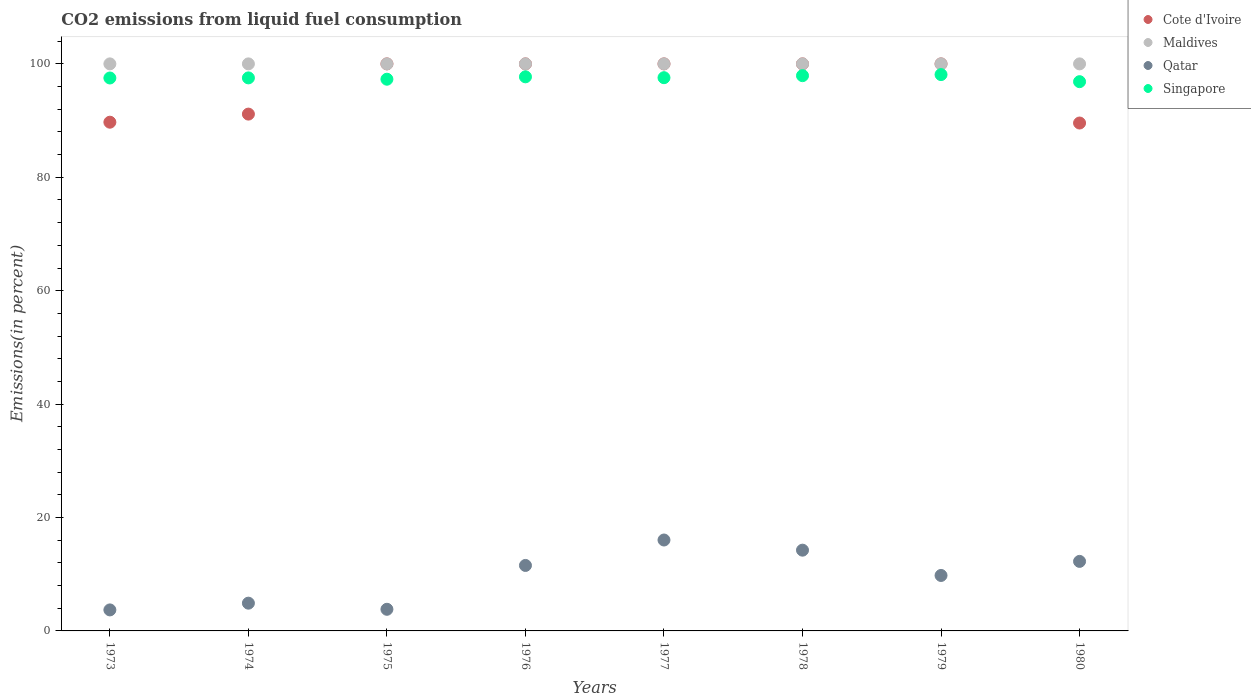How many different coloured dotlines are there?
Your response must be concise. 4. What is the total CO2 emitted in Singapore in 1975?
Provide a succinct answer. 97.3. Across all years, what is the maximum total CO2 emitted in Maldives?
Give a very brief answer. 100. In which year was the total CO2 emitted in Cote d'Ivoire maximum?
Make the answer very short. 1975. In which year was the total CO2 emitted in Maldives minimum?
Your response must be concise. 1973. What is the total total CO2 emitted in Cote d'Ivoire in the graph?
Provide a short and direct response. 770.43. What is the difference between the total CO2 emitted in Maldives in 1974 and that in 1980?
Make the answer very short. 0. What is the difference between the total CO2 emitted in Maldives in 1975 and the total CO2 emitted in Qatar in 1977?
Provide a succinct answer. 83.97. In the year 1974, what is the difference between the total CO2 emitted in Qatar and total CO2 emitted in Maldives?
Offer a terse response. -95.1. What is the ratio of the total CO2 emitted in Singapore in 1974 to that in 1978?
Your response must be concise. 1. Is the total CO2 emitted in Singapore in 1973 less than that in 1974?
Give a very brief answer. Yes. What is the difference between the highest and the second highest total CO2 emitted in Qatar?
Offer a very short reply. 1.79. What is the difference between the highest and the lowest total CO2 emitted in Qatar?
Your answer should be very brief. 12.33. In how many years, is the total CO2 emitted in Cote d'Ivoire greater than the average total CO2 emitted in Cote d'Ivoire taken over all years?
Your answer should be compact. 5. Is the sum of the total CO2 emitted in Cote d'Ivoire in 1973 and 1976 greater than the maximum total CO2 emitted in Singapore across all years?
Your answer should be compact. Yes. Is it the case that in every year, the sum of the total CO2 emitted in Cote d'Ivoire and total CO2 emitted in Singapore  is greater than the total CO2 emitted in Maldives?
Provide a succinct answer. Yes. Is the total CO2 emitted in Maldives strictly greater than the total CO2 emitted in Cote d'Ivoire over the years?
Provide a succinct answer. No. What is the difference between two consecutive major ticks on the Y-axis?
Give a very brief answer. 20. Does the graph contain any zero values?
Make the answer very short. No. How many legend labels are there?
Provide a short and direct response. 4. What is the title of the graph?
Offer a very short reply. CO2 emissions from liquid fuel consumption. What is the label or title of the Y-axis?
Keep it short and to the point. Emissions(in percent). What is the Emissions(in percent) in Cote d'Ivoire in 1973?
Offer a very short reply. 89.71. What is the Emissions(in percent) in Qatar in 1973?
Give a very brief answer. 3.71. What is the Emissions(in percent) of Singapore in 1973?
Provide a succinct answer. 97.51. What is the Emissions(in percent) in Cote d'Ivoire in 1974?
Make the answer very short. 91.14. What is the Emissions(in percent) of Maldives in 1974?
Make the answer very short. 100. What is the Emissions(in percent) of Qatar in 1974?
Provide a succinct answer. 4.9. What is the Emissions(in percent) in Singapore in 1974?
Offer a terse response. 97.53. What is the Emissions(in percent) in Cote d'Ivoire in 1975?
Your response must be concise. 100. What is the Emissions(in percent) in Qatar in 1975?
Offer a terse response. 3.82. What is the Emissions(in percent) in Singapore in 1975?
Provide a succinct answer. 97.3. What is the Emissions(in percent) of Qatar in 1976?
Your answer should be very brief. 11.55. What is the Emissions(in percent) of Singapore in 1976?
Your answer should be very brief. 97.72. What is the Emissions(in percent) in Cote d'Ivoire in 1977?
Your answer should be compact. 100. What is the Emissions(in percent) in Qatar in 1977?
Your answer should be very brief. 16.03. What is the Emissions(in percent) in Singapore in 1977?
Provide a short and direct response. 97.56. What is the Emissions(in percent) of Cote d'Ivoire in 1978?
Offer a terse response. 100. What is the Emissions(in percent) of Maldives in 1978?
Offer a terse response. 100. What is the Emissions(in percent) of Qatar in 1978?
Offer a very short reply. 14.24. What is the Emissions(in percent) of Singapore in 1978?
Provide a succinct answer. 97.92. What is the Emissions(in percent) of Maldives in 1979?
Ensure brevity in your answer.  100. What is the Emissions(in percent) of Qatar in 1979?
Keep it short and to the point. 9.78. What is the Emissions(in percent) of Singapore in 1979?
Make the answer very short. 98.11. What is the Emissions(in percent) in Cote d'Ivoire in 1980?
Offer a very short reply. 89.57. What is the Emissions(in percent) of Qatar in 1980?
Offer a terse response. 12.26. What is the Emissions(in percent) in Singapore in 1980?
Provide a succinct answer. 96.86. Across all years, what is the maximum Emissions(in percent) of Cote d'Ivoire?
Offer a terse response. 100. Across all years, what is the maximum Emissions(in percent) in Qatar?
Your answer should be compact. 16.03. Across all years, what is the maximum Emissions(in percent) in Singapore?
Give a very brief answer. 98.11. Across all years, what is the minimum Emissions(in percent) in Cote d'Ivoire?
Make the answer very short. 89.57. Across all years, what is the minimum Emissions(in percent) of Qatar?
Keep it short and to the point. 3.71. Across all years, what is the minimum Emissions(in percent) in Singapore?
Give a very brief answer. 96.86. What is the total Emissions(in percent) in Cote d'Ivoire in the graph?
Give a very brief answer. 770.43. What is the total Emissions(in percent) in Maldives in the graph?
Provide a succinct answer. 800. What is the total Emissions(in percent) in Qatar in the graph?
Your response must be concise. 76.28. What is the total Emissions(in percent) of Singapore in the graph?
Provide a short and direct response. 780.51. What is the difference between the Emissions(in percent) in Cote d'Ivoire in 1973 and that in 1974?
Make the answer very short. -1.43. What is the difference between the Emissions(in percent) in Maldives in 1973 and that in 1974?
Your response must be concise. 0. What is the difference between the Emissions(in percent) in Qatar in 1973 and that in 1974?
Your answer should be very brief. -1.19. What is the difference between the Emissions(in percent) of Singapore in 1973 and that in 1974?
Your answer should be very brief. -0.02. What is the difference between the Emissions(in percent) of Cote d'Ivoire in 1973 and that in 1975?
Your answer should be very brief. -10.29. What is the difference between the Emissions(in percent) in Qatar in 1973 and that in 1975?
Keep it short and to the point. -0.11. What is the difference between the Emissions(in percent) in Singapore in 1973 and that in 1975?
Your answer should be compact. 0.22. What is the difference between the Emissions(in percent) of Cote d'Ivoire in 1973 and that in 1976?
Offer a terse response. -10.29. What is the difference between the Emissions(in percent) in Qatar in 1973 and that in 1976?
Your answer should be very brief. -7.84. What is the difference between the Emissions(in percent) of Singapore in 1973 and that in 1976?
Provide a short and direct response. -0.21. What is the difference between the Emissions(in percent) in Cote d'Ivoire in 1973 and that in 1977?
Offer a terse response. -10.29. What is the difference between the Emissions(in percent) in Qatar in 1973 and that in 1977?
Your answer should be compact. -12.33. What is the difference between the Emissions(in percent) of Singapore in 1973 and that in 1977?
Provide a short and direct response. -0.05. What is the difference between the Emissions(in percent) in Cote d'Ivoire in 1973 and that in 1978?
Your answer should be very brief. -10.29. What is the difference between the Emissions(in percent) of Qatar in 1973 and that in 1978?
Your answer should be compact. -10.54. What is the difference between the Emissions(in percent) in Singapore in 1973 and that in 1978?
Provide a short and direct response. -0.41. What is the difference between the Emissions(in percent) of Cote d'Ivoire in 1973 and that in 1979?
Provide a succinct answer. -10.29. What is the difference between the Emissions(in percent) in Maldives in 1973 and that in 1979?
Your answer should be very brief. 0. What is the difference between the Emissions(in percent) in Qatar in 1973 and that in 1979?
Give a very brief answer. -6.07. What is the difference between the Emissions(in percent) in Singapore in 1973 and that in 1979?
Offer a terse response. -0.6. What is the difference between the Emissions(in percent) of Cote d'Ivoire in 1973 and that in 1980?
Offer a very short reply. 0.14. What is the difference between the Emissions(in percent) of Qatar in 1973 and that in 1980?
Provide a short and direct response. -8.56. What is the difference between the Emissions(in percent) of Singapore in 1973 and that in 1980?
Keep it short and to the point. 0.65. What is the difference between the Emissions(in percent) of Cote d'Ivoire in 1974 and that in 1975?
Your response must be concise. -8.86. What is the difference between the Emissions(in percent) of Maldives in 1974 and that in 1975?
Give a very brief answer. 0. What is the difference between the Emissions(in percent) in Qatar in 1974 and that in 1975?
Your answer should be very brief. 1.08. What is the difference between the Emissions(in percent) of Singapore in 1974 and that in 1975?
Your answer should be very brief. 0.23. What is the difference between the Emissions(in percent) of Cote d'Ivoire in 1974 and that in 1976?
Ensure brevity in your answer.  -8.86. What is the difference between the Emissions(in percent) in Maldives in 1974 and that in 1976?
Offer a terse response. 0. What is the difference between the Emissions(in percent) in Qatar in 1974 and that in 1976?
Ensure brevity in your answer.  -6.65. What is the difference between the Emissions(in percent) in Singapore in 1974 and that in 1976?
Your answer should be very brief. -0.19. What is the difference between the Emissions(in percent) of Cote d'Ivoire in 1974 and that in 1977?
Your answer should be very brief. -8.86. What is the difference between the Emissions(in percent) in Qatar in 1974 and that in 1977?
Your response must be concise. -11.14. What is the difference between the Emissions(in percent) of Singapore in 1974 and that in 1977?
Offer a very short reply. -0.04. What is the difference between the Emissions(in percent) in Cote d'Ivoire in 1974 and that in 1978?
Offer a very short reply. -8.86. What is the difference between the Emissions(in percent) in Qatar in 1974 and that in 1978?
Make the answer very short. -9.35. What is the difference between the Emissions(in percent) in Singapore in 1974 and that in 1978?
Offer a very short reply. -0.39. What is the difference between the Emissions(in percent) in Cote d'Ivoire in 1974 and that in 1979?
Your answer should be compact. -8.86. What is the difference between the Emissions(in percent) in Qatar in 1974 and that in 1979?
Provide a short and direct response. -4.89. What is the difference between the Emissions(in percent) of Singapore in 1974 and that in 1979?
Your answer should be compact. -0.58. What is the difference between the Emissions(in percent) in Cote d'Ivoire in 1974 and that in 1980?
Your answer should be compact. 1.57. What is the difference between the Emissions(in percent) in Qatar in 1974 and that in 1980?
Your response must be concise. -7.37. What is the difference between the Emissions(in percent) in Singapore in 1974 and that in 1980?
Keep it short and to the point. 0.67. What is the difference between the Emissions(in percent) of Cote d'Ivoire in 1975 and that in 1976?
Provide a succinct answer. 0. What is the difference between the Emissions(in percent) of Qatar in 1975 and that in 1976?
Your answer should be compact. -7.73. What is the difference between the Emissions(in percent) in Singapore in 1975 and that in 1976?
Ensure brevity in your answer.  -0.42. What is the difference between the Emissions(in percent) in Qatar in 1975 and that in 1977?
Keep it short and to the point. -12.22. What is the difference between the Emissions(in percent) of Singapore in 1975 and that in 1977?
Provide a succinct answer. -0.27. What is the difference between the Emissions(in percent) in Cote d'Ivoire in 1975 and that in 1978?
Make the answer very short. 0. What is the difference between the Emissions(in percent) in Qatar in 1975 and that in 1978?
Offer a very short reply. -10.43. What is the difference between the Emissions(in percent) of Singapore in 1975 and that in 1978?
Make the answer very short. -0.63. What is the difference between the Emissions(in percent) in Cote d'Ivoire in 1975 and that in 1979?
Your response must be concise. 0. What is the difference between the Emissions(in percent) of Maldives in 1975 and that in 1979?
Give a very brief answer. 0. What is the difference between the Emissions(in percent) of Qatar in 1975 and that in 1979?
Provide a short and direct response. -5.97. What is the difference between the Emissions(in percent) of Singapore in 1975 and that in 1979?
Give a very brief answer. -0.82. What is the difference between the Emissions(in percent) of Cote d'Ivoire in 1975 and that in 1980?
Offer a terse response. 10.43. What is the difference between the Emissions(in percent) in Qatar in 1975 and that in 1980?
Make the answer very short. -8.45. What is the difference between the Emissions(in percent) in Singapore in 1975 and that in 1980?
Offer a terse response. 0.43. What is the difference between the Emissions(in percent) of Qatar in 1976 and that in 1977?
Give a very brief answer. -4.49. What is the difference between the Emissions(in percent) of Singapore in 1976 and that in 1977?
Offer a very short reply. 0.15. What is the difference between the Emissions(in percent) of Qatar in 1976 and that in 1978?
Provide a succinct answer. -2.69. What is the difference between the Emissions(in percent) in Singapore in 1976 and that in 1978?
Your response must be concise. -0.2. What is the difference between the Emissions(in percent) in Cote d'Ivoire in 1976 and that in 1979?
Your answer should be very brief. 0. What is the difference between the Emissions(in percent) in Qatar in 1976 and that in 1979?
Ensure brevity in your answer.  1.77. What is the difference between the Emissions(in percent) in Singapore in 1976 and that in 1979?
Your response must be concise. -0.39. What is the difference between the Emissions(in percent) in Cote d'Ivoire in 1976 and that in 1980?
Offer a very short reply. 10.43. What is the difference between the Emissions(in percent) in Qatar in 1976 and that in 1980?
Provide a short and direct response. -0.72. What is the difference between the Emissions(in percent) in Singapore in 1976 and that in 1980?
Ensure brevity in your answer.  0.86. What is the difference between the Emissions(in percent) of Cote d'Ivoire in 1977 and that in 1978?
Provide a short and direct response. 0. What is the difference between the Emissions(in percent) in Maldives in 1977 and that in 1978?
Offer a very short reply. 0. What is the difference between the Emissions(in percent) in Qatar in 1977 and that in 1978?
Ensure brevity in your answer.  1.79. What is the difference between the Emissions(in percent) of Singapore in 1977 and that in 1978?
Make the answer very short. -0.36. What is the difference between the Emissions(in percent) of Maldives in 1977 and that in 1979?
Your answer should be compact. 0. What is the difference between the Emissions(in percent) of Qatar in 1977 and that in 1979?
Make the answer very short. 6.25. What is the difference between the Emissions(in percent) in Singapore in 1977 and that in 1979?
Your response must be concise. -0.55. What is the difference between the Emissions(in percent) of Cote d'Ivoire in 1977 and that in 1980?
Give a very brief answer. 10.43. What is the difference between the Emissions(in percent) in Maldives in 1977 and that in 1980?
Make the answer very short. 0. What is the difference between the Emissions(in percent) of Qatar in 1977 and that in 1980?
Your answer should be very brief. 3.77. What is the difference between the Emissions(in percent) in Singapore in 1977 and that in 1980?
Your answer should be compact. 0.7. What is the difference between the Emissions(in percent) of Cote d'Ivoire in 1978 and that in 1979?
Make the answer very short. 0. What is the difference between the Emissions(in percent) in Qatar in 1978 and that in 1979?
Keep it short and to the point. 4.46. What is the difference between the Emissions(in percent) in Singapore in 1978 and that in 1979?
Your answer should be compact. -0.19. What is the difference between the Emissions(in percent) in Cote d'Ivoire in 1978 and that in 1980?
Your answer should be very brief. 10.43. What is the difference between the Emissions(in percent) in Maldives in 1978 and that in 1980?
Offer a very short reply. 0. What is the difference between the Emissions(in percent) in Qatar in 1978 and that in 1980?
Offer a very short reply. 1.98. What is the difference between the Emissions(in percent) in Singapore in 1978 and that in 1980?
Make the answer very short. 1.06. What is the difference between the Emissions(in percent) of Cote d'Ivoire in 1979 and that in 1980?
Your answer should be very brief. 10.43. What is the difference between the Emissions(in percent) in Maldives in 1979 and that in 1980?
Offer a terse response. 0. What is the difference between the Emissions(in percent) of Qatar in 1979 and that in 1980?
Ensure brevity in your answer.  -2.48. What is the difference between the Emissions(in percent) in Singapore in 1979 and that in 1980?
Provide a succinct answer. 1.25. What is the difference between the Emissions(in percent) in Cote d'Ivoire in 1973 and the Emissions(in percent) in Maldives in 1974?
Offer a terse response. -10.29. What is the difference between the Emissions(in percent) of Cote d'Ivoire in 1973 and the Emissions(in percent) of Qatar in 1974?
Offer a terse response. 84.82. What is the difference between the Emissions(in percent) of Cote d'Ivoire in 1973 and the Emissions(in percent) of Singapore in 1974?
Provide a short and direct response. -7.82. What is the difference between the Emissions(in percent) in Maldives in 1973 and the Emissions(in percent) in Qatar in 1974?
Your answer should be very brief. 95.1. What is the difference between the Emissions(in percent) of Maldives in 1973 and the Emissions(in percent) of Singapore in 1974?
Make the answer very short. 2.47. What is the difference between the Emissions(in percent) of Qatar in 1973 and the Emissions(in percent) of Singapore in 1974?
Ensure brevity in your answer.  -93.82. What is the difference between the Emissions(in percent) of Cote d'Ivoire in 1973 and the Emissions(in percent) of Maldives in 1975?
Offer a very short reply. -10.29. What is the difference between the Emissions(in percent) in Cote d'Ivoire in 1973 and the Emissions(in percent) in Qatar in 1975?
Your answer should be very brief. 85.9. What is the difference between the Emissions(in percent) in Cote d'Ivoire in 1973 and the Emissions(in percent) in Singapore in 1975?
Your response must be concise. -7.58. What is the difference between the Emissions(in percent) in Maldives in 1973 and the Emissions(in percent) in Qatar in 1975?
Make the answer very short. 96.18. What is the difference between the Emissions(in percent) in Maldives in 1973 and the Emissions(in percent) in Singapore in 1975?
Make the answer very short. 2.7. What is the difference between the Emissions(in percent) of Qatar in 1973 and the Emissions(in percent) of Singapore in 1975?
Offer a very short reply. -93.59. What is the difference between the Emissions(in percent) in Cote d'Ivoire in 1973 and the Emissions(in percent) in Maldives in 1976?
Offer a very short reply. -10.29. What is the difference between the Emissions(in percent) in Cote d'Ivoire in 1973 and the Emissions(in percent) in Qatar in 1976?
Ensure brevity in your answer.  78.17. What is the difference between the Emissions(in percent) of Cote d'Ivoire in 1973 and the Emissions(in percent) of Singapore in 1976?
Your answer should be compact. -8. What is the difference between the Emissions(in percent) of Maldives in 1973 and the Emissions(in percent) of Qatar in 1976?
Provide a short and direct response. 88.45. What is the difference between the Emissions(in percent) of Maldives in 1973 and the Emissions(in percent) of Singapore in 1976?
Offer a very short reply. 2.28. What is the difference between the Emissions(in percent) in Qatar in 1973 and the Emissions(in percent) in Singapore in 1976?
Give a very brief answer. -94.01. What is the difference between the Emissions(in percent) in Cote d'Ivoire in 1973 and the Emissions(in percent) in Maldives in 1977?
Provide a short and direct response. -10.29. What is the difference between the Emissions(in percent) of Cote d'Ivoire in 1973 and the Emissions(in percent) of Qatar in 1977?
Offer a very short reply. 73.68. What is the difference between the Emissions(in percent) in Cote d'Ivoire in 1973 and the Emissions(in percent) in Singapore in 1977?
Keep it short and to the point. -7.85. What is the difference between the Emissions(in percent) in Maldives in 1973 and the Emissions(in percent) in Qatar in 1977?
Make the answer very short. 83.97. What is the difference between the Emissions(in percent) of Maldives in 1973 and the Emissions(in percent) of Singapore in 1977?
Your answer should be compact. 2.44. What is the difference between the Emissions(in percent) of Qatar in 1973 and the Emissions(in percent) of Singapore in 1977?
Provide a succinct answer. -93.86. What is the difference between the Emissions(in percent) in Cote d'Ivoire in 1973 and the Emissions(in percent) in Maldives in 1978?
Provide a succinct answer. -10.29. What is the difference between the Emissions(in percent) of Cote d'Ivoire in 1973 and the Emissions(in percent) of Qatar in 1978?
Provide a short and direct response. 75.47. What is the difference between the Emissions(in percent) in Cote d'Ivoire in 1973 and the Emissions(in percent) in Singapore in 1978?
Provide a short and direct response. -8.21. What is the difference between the Emissions(in percent) of Maldives in 1973 and the Emissions(in percent) of Qatar in 1978?
Ensure brevity in your answer.  85.76. What is the difference between the Emissions(in percent) of Maldives in 1973 and the Emissions(in percent) of Singapore in 1978?
Give a very brief answer. 2.08. What is the difference between the Emissions(in percent) in Qatar in 1973 and the Emissions(in percent) in Singapore in 1978?
Offer a terse response. -94.22. What is the difference between the Emissions(in percent) in Cote d'Ivoire in 1973 and the Emissions(in percent) in Maldives in 1979?
Give a very brief answer. -10.29. What is the difference between the Emissions(in percent) in Cote d'Ivoire in 1973 and the Emissions(in percent) in Qatar in 1979?
Keep it short and to the point. 79.93. What is the difference between the Emissions(in percent) of Cote d'Ivoire in 1973 and the Emissions(in percent) of Singapore in 1979?
Your response must be concise. -8.4. What is the difference between the Emissions(in percent) of Maldives in 1973 and the Emissions(in percent) of Qatar in 1979?
Your response must be concise. 90.22. What is the difference between the Emissions(in percent) in Maldives in 1973 and the Emissions(in percent) in Singapore in 1979?
Your response must be concise. 1.89. What is the difference between the Emissions(in percent) in Qatar in 1973 and the Emissions(in percent) in Singapore in 1979?
Offer a very short reply. -94.41. What is the difference between the Emissions(in percent) in Cote d'Ivoire in 1973 and the Emissions(in percent) in Maldives in 1980?
Offer a terse response. -10.29. What is the difference between the Emissions(in percent) of Cote d'Ivoire in 1973 and the Emissions(in percent) of Qatar in 1980?
Your answer should be compact. 77.45. What is the difference between the Emissions(in percent) of Cote d'Ivoire in 1973 and the Emissions(in percent) of Singapore in 1980?
Your answer should be very brief. -7.15. What is the difference between the Emissions(in percent) of Maldives in 1973 and the Emissions(in percent) of Qatar in 1980?
Your answer should be very brief. 87.74. What is the difference between the Emissions(in percent) of Maldives in 1973 and the Emissions(in percent) of Singapore in 1980?
Your answer should be very brief. 3.14. What is the difference between the Emissions(in percent) of Qatar in 1973 and the Emissions(in percent) of Singapore in 1980?
Offer a terse response. -93.16. What is the difference between the Emissions(in percent) in Cote d'Ivoire in 1974 and the Emissions(in percent) in Maldives in 1975?
Offer a very short reply. -8.86. What is the difference between the Emissions(in percent) of Cote d'Ivoire in 1974 and the Emissions(in percent) of Qatar in 1975?
Your answer should be very brief. 87.33. What is the difference between the Emissions(in percent) of Cote d'Ivoire in 1974 and the Emissions(in percent) of Singapore in 1975?
Keep it short and to the point. -6.15. What is the difference between the Emissions(in percent) of Maldives in 1974 and the Emissions(in percent) of Qatar in 1975?
Make the answer very short. 96.18. What is the difference between the Emissions(in percent) of Maldives in 1974 and the Emissions(in percent) of Singapore in 1975?
Offer a terse response. 2.7. What is the difference between the Emissions(in percent) of Qatar in 1974 and the Emissions(in percent) of Singapore in 1975?
Make the answer very short. -92.4. What is the difference between the Emissions(in percent) of Cote d'Ivoire in 1974 and the Emissions(in percent) of Maldives in 1976?
Keep it short and to the point. -8.86. What is the difference between the Emissions(in percent) of Cote d'Ivoire in 1974 and the Emissions(in percent) of Qatar in 1976?
Provide a succinct answer. 79.6. What is the difference between the Emissions(in percent) in Cote d'Ivoire in 1974 and the Emissions(in percent) in Singapore in 1976?
Offer a terse response. -6.57. What is the difference between the Emissions(in percent) in Maldives in 1974 and the Emissions(in percent) in Qatar in 1976?
Your answer should be very brief. 88.45. What is the difference between the Emissions(in percent) in Maldives in 1974 and the Emissions(in percent) in Singapore in 1976?
Your answer should be compact. 2.28. What is the difference between the Emissions(in percent) in Qatar in 1974 and the Emissions(in percent) in Singapore in 1976?
Make the answer very short. -92.82. What is the difference between the Emissions(in percent) in Cote d'Ivoire in 1974 and the Emissions(in percent) in Maldives in 1977?
Give a very brief answer. -8.86. What is the difference between the Emissions(in percent) of Cote d'Ivoire in 1974 and the Emissions(in percent) of Qatar in 1977?
Provide a succinct answer. 75.11. What is the difference between the Emissions(in percent) of Cote d'Ivoire in 1974 and the Emissions(in percent) of Singapore in 1977?
Give a very brief answer. -6.42. What is the difference between the Emissions(in percent) in Maldives in 1974 and the Emissions(in percent) in Qatar in 1977?
Provide a succinct answer. 83.97. What is the difference between the Emissions(in percent) in Maldives in 1974 and the Emissions(in percent) in Singapore in 1977?
Provide a succinct answer. 2.44. What is the difference between the Emissions(in percent) in Qatar in 1974 and the Emissions(in percent) in Singapore in 1977?
Provide a short and direct response. -92.67. What is the difference between the Emissions(in percent) of Cote d'Ivoire in 1974 and the Emissions(in percent) of Maldives in 1978?
Give a very brief answer. -8.86. What is the difference between the Emissions(in percent) of Cote d'Ivoire in 1974 and the Emissions(in percent) of Qatar in 1978?
Give a very brief answer. 76.9. What is the difference between the Emissions(in percent) of Cote d'Ivoire in 1974 and the Emissions(in percent) of Singapore in 1978?
Offer a very short reply. -6.78. What is the difference between the Emissions(in percent) in Maldives in 1974 and the Emissions(in percent) in Qatar in 1978?
Your response must be concise. 85.76. What is the difference between the Emissions(in percent) of Maldives in 1974 and the Emissions(in percent) of Singapore in 1978?
Offer a very short reply. 2.08. What is the difference between the Emissions(in percent) in Qatar in 1974 and the Emissions(in percent) in Singapore in 1978?
Keep it short and to the point. -93.03. What is the difference between the Emissions(in percent) in Cote d'Ivoire in 1974 and the Emissions(in percent) in Maldives in 1979?
Your answer should be very brief. -8.86. What is the difference between the Emissions(in percent) in Cote d'Ivoire in 1974 and the Emissions(in percent) in Qatar in 1979?
Offer a very short reply. 81.36. What is the difference between the Emissions(in percent) of Cote d'Ivoire in 1974 and the Emissions(in percent) of Singapore in 1979?
Provide a short and direct response. -6.97. What is the difference between the Emissions(in percent) of Maldives in 1974 and the Emissions(in percent) of Qatar in 1979?
Offer a terse response. 90.22. What is the difference between the Emissions(in percent) in Maldives in 1974 and the Emissions(in percent) in Singapore in 1979?
Offer a very short reply. 1.89. What is the difference between the Emissions(in percent) of Qatar in 1974 and the Emissions(in percent) of Singapore in 1979?
Provide a short and direct response. -93.22. What is the difference between the Emissions(in percent) of Cote d'Ivoire in 1974 and the Emissions(in percent) of Maldives in 1980?
Make the answer very short. -8.86. What is the difference between the Emissions(in percent) of Cote d'Ivoire in 1974 and the Emissions(in percent) of Qatar in 1980?
Give a very brief answer. 78.88. What is the difference between the Emissions(in percent) in Cote d'Ivoire in 1974 and the Emissions(in percent) in Singapore in 1980?
Give a very brief answer. -5.72. What is the difference between the Emissions(in percent) in Maldives in 1974 and the Emissions(in percent) in Qatar in 1980?
Make the answer very short. 87.74. What is the difference between the Emissions(in percent) in Maldives in 1974 and the Emissions(in percent) in Singapore in 1980?
Make the answer very short. 3.14. What is the difference between the Emissions(in percent) of Qatar in 1974 and the Emissions(in percent) of Singapore in 1980?
Provide a short and direct response. -91.97. What is the difference between the Emissions(in percent) of Cote d'Ivoire in 1975 and the Emissions(in percent) of Qatar in 1976?
Make the answer very short. 88.45. What is the difference between the Emissions(in percent) in Cote d'Ivoire in 1975 and the Emissions(in percent) in Singapore in 1976?
Your answer should be compact. 2.28. What is the difference between the Emissions(in percent) in Maldives in 1975 and the Emissions(in percent) in Qatar in 1976?
Ensure brevity in your answer.  88.45. What is the difference between the Emissions(in percent) in Maldives in 1975 and the Emissions(in percent) in Singapore in 1976?
Your answer should be very brief. 2.28. What is the difference between the Emissions(in percent) of Qatar in 1975 and the Emissions(in percent) of Singapore in 1976?
Your answer should be compact. -93.9. What is the difference between the Emissions(in percent) in Cote d'Ivoire in 1975 and the Emissions(in percent) in Maldives in 1977?
Ensure brevity in your answer.  0. What is the difference between the Emissions(in percent) in Cote d'Ivoire in 1975 and the Emissions(in percent) in Qatar in 1977?
Provide a succinct answer. 83.97. What is the difference between the Emissions(in percent) in Cote d'Ivoire in 1975 and the Emissions(in percent) in Singapore in 1977?
Your answer should be very brief. 2.44. What is the difference between the Emissions(in percent) of Maldives in 1975 and the Emissions(in percent) of Qatar in 1977?
Provide a short and direct response. 83.97. What is the difference between the Emissions(in percent) in Maldives in 1975 and the Emissions(in percent) in Singapore in 1977?
Provide a short and direct response. 2.44. What is the difference between the Emissions(in percent) in Qatar in 1975 and the Emissions(in percent) in Singapore in 1977?
Give a very brief answer. -93.75. What is the difference between the Emissions(in percent) of Cote d'Ivoire in 1975 and the Emissions(in percent) of Qatar in 1978?
Make the answer very short. 85.76. What is the difference between the Emissions(in percent) in Cote d'Ivoire in 1975 and the Emissions(in percent) in Singapore in 1978?
Make the answer very short. 2.08. What is the difference between the Emissions(in percent) in Maldives in 1975 and the Emissions(in percent) in Qatar in 1978?
Your answer should be compact. 85.76. What is the difference between the Emissions(in percent) in Maldives in 1975 and the Emissions(in percent) in Singapore in 1978?
Your answer should be very brief. 2.08. What is the difference between the Emissions(in percent) in Qatar in 1975 and the Emissions(in percent) in Singapore in 1978?
Give a very brief answer. -94.11. What is the difference between the Emissions(in percent) of Cote d'Ivoire in 1975 and the Emissions(in percent) of Qatar in 1979?
Provide a succinct answer. 90.22. What is the difference between the Emissions(in percent) of Cote d'Ivoire in 1975 and the Emissions(in percent) of Singapore in 1979?
Make the answer very short. 1.89. What is the difference between the Emissions(in percent) in Maldives in 1975 and the Emissions(in percent) in Qatar in 1979?
Offer a terse response. 90.22. What is the difference between the Emissions(in percent) in Maldives in 1975 and the Emissions(in percent) in Singapore in 1979?
Offer a very short reply. 1.89. What is the difference between the Emissions(in percent) of Qatar in 1975 and the Emissions(in percent) of Singapore in 1979?
Make the answer very short. -94.3. What is the difference between the Emissions(in percent) in Cote d'Ivoire in 1975 and the Emissions(in percent) in Maldives in 1980?
Make the answer very short. 0. What is the difference between the Emissions(in percent) of Cote d'Ivoire in 1975 and the Emissions(in percent) of Qatar in 1980?
Your response must be concise. 87.74. What is the difference between the Emissions(in percent) of Cote d'Ivoire in 1975 and the Emissions(in percent) of Singapore in 1980?
Your response must be concise. 3.14. What is the difference between the Emissions(in percent) in Maldives in 1975 and the Emissions(in percent) in Qatar in 1980?
Provide a short and direct response. 87.74. What is the difference between the Emissions(in percent) in Maldives in 1975 and the Emissions(in percent) in Singapore in 1980?
Provide a succinct answer. 3.14. What is the difference between the Emissions(in percent) of Qatar in 1975 and the Emissions(in percent) of Singapore in 1980?
Offer a very short reply. -93.05. What is the difference between the Emissions(in percent) of Cote d'Ivoire in 1976 and the Emissions(in percent) of Qatar in 1977?
Your response must be concise. 83.97. What is the difference between the Emissions(in percent) in Cote d'Ivoire in 1976 and the Emissions(in percent) in Singapore in 1977?
Make the answer very short. 2.44. What is the difference between the Emissions(in percent) in Maldives in 1976 and the Emissions(in percent) in Qatar in 1977?
Your response must be concise. 83.97. What is the difference between the Emissions(in percent) of Maldives in 1976 and the Emissions(in percent) of Singapore in 1977?
Your answer should be compact. 2.44. What is the difference between the Emissions(in percent) in Qatar in 1976 and the Emissions(in percent) in Singapore in 1977?
Offer a very short reply. -86.02. What is the difference between the Emissions(in percent) of Cote d'Ivoire in 1976 and the Emissions(in percent) of Maldives in 1978?
Provide a succinct answer. 0. What is the difference between the Emissions(in percent) of Cote d'Ivoire in 1976 and the Emissions(in percent) of Qatar in 1978?
Your answer should be compact. 85.76. What is the difference between the Emissions(in percent) of Cote d'Ivoire in 1976 and the Emissions(in percent) of Singapore in 1978?
Offer a very short reply. 2.08. What is the difference between the Emissions(in percent) in Maldives in 1976 and the Emissions(in percent) in Qatar in 1978?
Keep it short and to the point. 85.76. What is the difference between the Emissions(in percent) of Maldives in 1976 and the Emissions(in percent) of Singapore in 1978?
Make the answer very short. 2.08. What is the difference between the Emissions(in percent) of Qatar in 1976 and the Emissions(in percent) of Singapore in 1978?
Ensure brevity in your answer.  -86.37. What is the difference between the Emissions(in percent) of Cote d'Ivoire in 1976 and the Emissions(in percent) of Maldives in 1979?
Give a very brief answer. 0. What is the difference between the Emissions(in percent) in Cote d'Ivoire in 1976 and the Emissions(in percent) in Qatar in 1979?
Your answer should be very brief. 90.22. What is the difference between the Emissions(in percent) in Cote d'Ivoire in 1976 and the Emissions(in percent) in Singapore in 1979?
Provide a succinct answer. 1.89. What is the difference between the Emissions(in percent) of Maldives in 1976 and the Emissions(in percent) of Qatar in 1979?
Ensure brevity in your answer.  90.22. What is the difference between the Emissions(in percent) of Maldives in 1976 and the Emissions(in percent) of Singapore in 1979?
Offer a terse response. 1.89. What is the difference between the Emissions(in percent) of Qatar in 1976 and the Emissions(in percent) of Singapore in 1979?
Make the answer very short. -86.57. What is the difference between the Emissions(in percent) of Cote d'Ivoire in 1976 and the Emissions(in percent) of Maldives in 1980?
Offer a very short reply. 0. What is the difference between the Emissions(in percent) in Cote d'Ivoire in 1976 and the Emissions(in percent) in Qatar in 1980?
Your answer should be compact. 87.74. What is the difference between the Emissions(in percent) in Cote d'Ivoire in 1976 and the Emissions(in percent) in Singapore in 1980?
Make the answer very short. 3.14. What is the difference between the Emissions(in percent) of Maldives in 1976 and the Emissions(in percent) of Qatar in 1980?
Your answer should be very brief. 87.74. What is the difference between the Emissions(in percent) of Maldives in 1976 and the Emissions(in percent) of Singapore in 1980?
Your response must be concise. 3.14. What is the difference between the Emissions(in percent) in Qatar in 1976 and the Emissions(in percent) in Singapore in 1980?
Provide a succinct answer. -85.32. What is the difference between the Emissions(in percent) in Cote d'Ivoire in 1977 and the Emissions(in percent) in Maldives in 1978?
Offer a very short reply. 0. What is the difference between the Emissions(in percent) of Cote d'Ivoire in 1977 and the Emissions(in percent) of Qatar in 1978?
Provide a succinct answer. 85.76. What is the difference between the Emissions(in percent) in Cote d'Ivoire in 1977 and the Emissions(in percent) in Singapore in 1978?
Your answer should be very brief. 2.08. What is the difference between the Emissions(in percent) in Maldives in 1977 and the Emissions(in percent) in Qatar in 1978?
Your response must be concise. 85.76. What is the difference between the Emissions(in percent) in Maldives in 1977 and the Emissions(in percent) in Singapore in 1978?
Your answer should be compact. 2.08. What is the difference between the Emissions(in percent) in Qatar in 1977 and the Emissions(in percent) in Singapore in 1978?
Offer a terse response. -81.89. What is the difference between the Emissions(in percent) of Cote d'Ivoire in 1977 and the Emissions(in percent) of Qatar in 1979?
Give a very brief answer. 90.22. What is the difference between the Emissions(in percent) of Cote d'Ivoire in 1977 and the Emissions(in percent) of Singapore in 1979?
Your answer should be very brief. 1.89. What is the difference between the Emissions(in percent) in Maldives in 1977 and the Emissions(in percent) in Qatar in 1979?
Your answer should be compact. 90.22. What is the difference between the Emissions(in percent) in Maldives in 1977 and the Emissions(in percent) in Singapore in 1979?
Your answer should be very brief. 1.89. What is the difference between the Emissions(in percent) of Qatar in 1977 and the Emissions(in percent) of Singapore in 1979?
Your answer should be very brief. -82.08. What is the difference between the Emissions(in percent) in Cote d'Ivoire in 1977 and the Emissions(in percent) in Maldives in 1980?
Provide a succinct answer. 0. What is the difference between the Emissions(in percent) in Cote d'Ivoire in 1977 and the Emissions(in percent) in Qatar in 1980?
Keep it short and to the point. 87.74. What is the difference between the Emissions(in percent) of Cote d'Ivoire in 1977 and the Emissions(in percent) of Singapore in 1980?
Provide a short and direct response. 3.14. What is the difference between the Emissions(in percent) of Maldives in 1977 and the Emissions(in percent) of Qatar in 1980?
Provide a short and direct response. 87.74. What is the difference between the Emissions(in percent) in Maldives in 1977 and the Emissions(in percent) in Singapore in 1980?
Give a very brief answer. 3.14. What is the difference between the Emissions(in percent) in Qatar in 1977 and the Emissions(in percent) in Singapore in 1980?
Make the answer very short. -80.83. What is the difference between the Emissions(in percent) of Cote d'Ivoire in 1978 and the Emissions(in percent) of Maldives in 1979?
Provide a short and direct response. 0. What is the difference between the Emissions(in percent) of Cote d'Ivoire in 1978 and the Emissions(in percent) of Qatar in 1979?
Offer a very short reply. 90.22. What is the difference between the Emissions(in percent) in Cote d'Ivoire in 1978 and the Emissions(in percent) in Singapore in 1979?
Provide a short and direct response. 1.89. What is the difference between the Emissions(in percent) of Maldives in 1978 and the Emissions(in percent) of Qatar in 1979?
Give a very brief answer. 90.22. What is the difference between the Emissions(in percent) of Maldives in 1978 and the Emissions(in percent) of Singapore in 1979?
Ensure brevity in your answer.  1.89. What is the difference between the Emissions(in percent) of Qatar in 1978 and the Emissions(in percent) of Singapore in 1979?
Provide a succinct answer. -83.87. What is the difference between the Emissions(in percent) of Cote d'Ivoire in 1978 and the Emissions(in percent) of Maldives in 1980?
Your answer should be very brief. 0. What is the difference between the Emissions(in percent) of Cote d'Ivoire in 1978 and the Emissions(in percent) of Qatar in 1980?
Give a very brief answer. 87.74. What is the difference between the Emissions(in percent) in Cote d'Ivoire in 1978 and the Emissions(in percent) in Singapore in 1980?
Your answer should be compact. 3.14. What is the difference between the Emissions(in percent) of Maldives in 1978 and the Emissions(in percent) of Qatar in 1980?
Provide a short and direct response. 87.74. What is the difference between the Emissions(in percent) of Maldives in 1978 and the Emissions(in percent) of Singapore in 1980?
Ensure brevity in your answer.  3.14. What is the difference between the Emissions(in percent) in Qatar in 1978 and the Emissions(in percent) in Singapore in 1980?
Ensure brevity in your answer.  -82.62. What is the difference between the Emissions(in percent) of Cote d'Ivoire in 1979 and the Emissions(in percent) of Maldives in 1980?
Provide a short and direct response. 0. What is the difference between the Emissions(in percent) in Cote d'Ivoire in 1979 and the Emissions(in percent) in Qatar in 1980?
Your answer should be very brief. 87.74. What is the difference between the Emissions(in percent) of Cote d'Ivoire in 1979 and the Emissions(in percent) of Singapore in 1980?
Keep it short and to the point. 3.14. What is the difference between the Emissions(in percent) of Maldives in 1979 and the Emissions(in percent) of Qatar in 1980?
Your answer should be compact. 87.74. What is the difference between the Emissions(in percent) in Maldives in 1979 and the Emissions(in percent) in Singapore in 1980?
Offer a very short reply. 3.14. What is the difference between the Emissions(in percent) of Qatar in 1979 and the Emissions(in percent) of Singapore in 1980?
Your answer should be very brief. -87.08. What is the average Emissions(in percent) of Cote d'Ivoire per year?
Your answer should be compact. 96.3. What is the average Emissions(in percent) in Qatar per year?
Keep it short and to the point. 9.53. What is the average Emissions(in percent) of Singapore per year?
Offer a terse response. 97.56. In the year 1973, what is the difference between the Emissions(in percent) of Cote d'Ivoire and Emissions(in percent) of Maldives?
Provide a succinct answer. -10.29. In the year 1973, what is the difference between the Emissions(in percent) of Cote d'Ivoire and Emissions(in percent) of Qatar?
Your answer should be very brief. 86.01. In the year 1973, what is the difference between the Emissions(in percent) of Cote d'Ivoire and Emissions(in percent) of Singapore?
Give a very brief answer. -7.8. In the year 1973, what is the difference between the Emissions(in percent) of Maldives and Emissions(in percent) of Qatar?
Offer a very short reply. 96.29. In the year 1973, what is the difference between the Emissions(in percent) of Maldives and Emissions(in percent) of Singapore?
Make the answer very short. 2.49. In the year 1973, what is the difference between the Emissions(in percent) in Qatar and Emissions(in percent) in Singapore?
Offer a terse response. -93.81. In the year 1974, what is the difference between the Emissions(in percent) in Cote d'Ivoire and Emissions(in percent) in Maldives?
Provide a succinct answer. -8.86. In the year 1974, what is the difference between the Emissions(in percent) of Cote d'Ivoire and Emissions(in percent) of Qatar?
Make the answer very short. 86.25. In the year 1974, what is the difference between the Emissions(in percent) of Cote d'Ivoire and Emissions(in percent) of Singapore?
Make the answer very short. -6.39. In the year 1974, what is the difference between the Emissions(in percent) in Maldives and Emissions(in percent) in Qatar?
Keep it short and to the point. 95.1. In the year 1974, what is the difference between the Emissions(in percent) of Maldives and Emissions(in percent) of Singapore?
Provide a succinct answer. 2.47. In the year 1974, what is the difference between the Emissions(in percent) of Qatar and Emissions(in percent) of Singapore?
Provide a short and direct response. -92.63. In the year 1975, what is the difference between the Emissions(in percent) in Cote d'Ivoire and Emissions(in percent) in Maldives?
Make the answer very short. 0. In the year 1975, what is the difference between the Emissions(in percent) of Cote d'Ivoire and Emissions(in percent) of Qatar?
Keep it short and to the point. 96.18. In the year 1975, what is the difference between the Emissions(in percent) in Cote d'Ivoire and Emissions(in percent) in Singapore?
Provide a succinct answer. 2.7. In the year 1975, what is the difference between the Emissions(in percent) in Maldives and Emissions(in percent) in Qatar?
Offer a terse response. 96.18. In the year 1975, what is the difference between the Emissions(in percent) of Maldives and Emissions(in percent) of Singapore?
Provide a succinct answer. 2.7. In the year 1975, what is the difference between the Emissions(in percent) in Qatar and Emissions(in percent) in Singapore?
Offer a terse response. -93.48. In the year 1976, what is the difference between the Emissions(in percent) in Cote d'Ivoire and Emissions(in percent) in Qatar?
Your answer should be very brief. 88.45. In the year 1976, what is the difference between the Emissions(in percent) in Cote d'Ivoire and Emissions(in percent) in Singapore?
Make the answer very short. 2.28. In the year 1976, what is the difference between the Emissions(in percent) of Maldives and Emissions(in percent) of Qatar?
Provide a short and direct response. 88.45. In the year 1976, what is the difference between the Emissions(in percent) in Maldives and Emissions(in percent) in Singapore?
Your answer should be very brief. 2.28. In the year 1976, what is the difference between the Emissions(in percent) of Qatar and Emissions(in percent) of Singapore?
Ensure brevity in your answer.  -86.17. In the year 1977, what is the difference between the Emissions(in percent) of Cote d'Ivoire and Emissions(in percent) of Maldives?
Your response must be concise. 0. In the year 1977, what is the difference between the Emissions(in percent) of Cote d'Ivoire and Emissions(in percent) of Qatar?
Your answer should be very brief. 83.97. In the year 1977, what is the difference between the Emissions(in percent) of Cote d'Ivoire and Emissions(in percent) of Singapore?
Keep it short and to the point. 2.44. In the year 1977, what is the difference between the Emissions(in percent) in Maldives and Emissions(in percent) in Qatar?
Your answer should be compact. 83.97. In the year 1977, what is the difference between the Emissions(in percent) in Maldives and Emissions(in percent) in Singapore?
Your answer should be compact. 2.44. In the year 1977, what is the difference between the Emissions(in percent) of Qatar and Emissions(in percent) of Singapore?
Provide a short and direct response. -81.53. In the year 1978, what is the difference between the Emissions(in percent) of Cote d'Ivoire and Emissions(in percent) of Maldives?
Offer a terse response. 0. In the year 1978, what is the difference between the Emissions(in percent) in Cote d'Ivoire and Emissions(in percent) in Qatar?
Offer a very short reply. 85.76. In the year 1978, what is the difference between the Emissions(in percent) in Cote d'Ivoire and Emissions(in percent) in Singapore?
Give a very brief answer. 2.08. In the year 1978, what is the difference between the Emissions(in percent) of Maldives and Emissions(in percent) of Qatar?
Your response must be concise. 85.76. In the year 1978, what is the difference between the Emissions(in percent) of Maldives and Emissions(in percent) of Singapore?
Provide a short and direct response. 2.08. In the year 1978, what is the difference between the Emissions(in percent) in Qatar and Emissions(in percent) in Singapore?
Make the answer very short. -83.68. In the year 1979, what is the difference between the Emissions(in percent) of Cote d'Ivoire and Emissions(in percent) of Maldives?
Provide a short and direct response. 0. In the year 1979, what is the difference between the Emissions(in percent) in Cote d'Ivoire and Emissions(in percent) in Qatar?
Your answer should be compact. 90.22. In the year 1979, what is the difference between the Emissions(in percent) of Cote d'Ivoire and Emissions(in percent) of Singapore?
Offer a terse response. 1.89. In the year 1979, what is the difference between the Emissions(in percent) of Maldives and Emissions(in percent) of Qatar?
Give a very brief answer. 90.22. In the year 1979, what is the difference between the Emissions(in percent) of Maldives and Emissions(in percent) of Singapore?
Your response must be concise. 1.89. In the year 1979, what is the difference between the Emissions(in percent) of Qatar and Emissions(in percent) of Singapore?
Keep it short and to the point. -88.33. In the year 1980, what is the difference between the Emissions(in percent) in Cote d'Ivoire and Emissions(in percent) in Maldives?
Provide a succinct answer. -10.43. In the year 1980, what is the difference between the Emissions(in percent) in Cote d'Ivoire and Emissions(in percent) in Qatar?
Your response must be concise. 77.31. In the year 1980, what is the difference between the Emissions(in percent) of Cote d'Ivoire and Emissions(in percent) of Singapore?
Offer a terse response. -7.29. In the year 1980, what is the difference between the Emissions(in percent) of Maldives and Emissions(in percent) of Qatar?
Your answer should be very brief. 87.74. In the year 1980, what is the difference between the Emissions(in percent) in Maldives and Emissions(in percent) in Singapore?
Your response must be concise. 3.14. In the year 1980, what is the difference between the Emissions(in percent) in Qatar and Emissions(in percent) in Singapore?
Offer a terse response. -84.6. What is the ratio of the Emissions(in percent) of Cote d'Ivoire in 1973 to that in 1974?
Your response must be concise. 0.98. What is the ratio of the Emissions(in percent) of Qatar in 1973 to that in 1974?
Offer a very short reply. 0.76. What is the ratio of the Emissions(in percent) in Cote d'Ivoire in 1973 to that in 1975?
Give a very brief answer. 0.9. What is the ratio of the Emissions(in percent) in Qatar in 1973 to that in 1975?
Your response must be concise. 0.97. What is the ratio of the Emissions(in percent) of Cote d'Ivoire in 1973 to that in 1976?
Keep it short and to the point. 0.9. What is the ratio of the Emissions(in percent) of Maldives in 1973 to that in 1976?
Your answer should be very brief. 1. What is the ratio of the Emissions(in percent) of Qatar in 1973 to that in 1976?
Your answer should be compact. 0.32. What is the ratio of the Emissions(in percent) in Singapore in 1973 to that in 1976?
Offer a terse response. 1. What is the ratio of the Emissions(in percent) in Cote d'Ivoire in 1973 to that in 1977?
Your answer should be compact. 0.9. What is the ratio of the Emissions(in percent) in Maldives in 1973 to that in 1977?
Provide a succinct answer. 1. What is the ratio of the Emissions(in percent) of Qatar in 1973 to that in 1977?
Your response must be concise. 0.23. What is the ratio of the Emissions(in percent) of Cote d'Ivoire in 1973 to that in 1978?
Offer a terse response. 0.9. What is the ratio of the Emissions(in percent) in Qatar in 1973 to that in 1978?
Your answer should be very brief. 0.26. What is the ratio of the Emissions(in percent) in Cote d'Ivoire in 1973 to that in 1979?
Offer a terse response. 0.9. What is the ratio of the Emissions(in percent) in Maldives in 1973 to that in 1979?
Your answer should be very brief. 1. What is the ratio of the Emissions(in percent) in Qatar in 1973 to that in 1979?
Give a very brief answer. 0.38. What is the ratio of the Emissions(in percent) of Maldives in 1973 to that in 1980?
Your response must be concise. 1. What is the ratio of the Emissions(in percent) in Qatar in 1973 to that in 1980?
Make the answer very short. 0.3. What is the ratio of the Emissions(in percent) in Singapore in 1973 to that in 1980?
Provide a succinct answer. 1.01. What is the ratio of the Emissions(in percent) of Cote d'Ivoire in 1974 to that in 1975?
Give a very brief answer. 0.91. What is the ratio of the Emissions(in percent) of Qatar in 1974 to that in 1975?
Your answer should be very brief. 1.28. What is the ratio of the Emissions(in percent) in Singapore in 1974 to that in 1975?
Offer a very short reply. 1. What is the ratio of the Emissions(in percent) in Cote d'Ivoire in 1974 to that in 1976?
Provide a short and direct response. 0.91. What is the ratio of the Emissions(in percent) of Qatar in 1974 to that in 1976?
Ensure brevity in your answer.  0.42. What is the ratio of the Emissions(in percent) in Cote d'Ivoire in 1974 to that in 1977?
Your answer should be compact. 0.91. What is the ratio of the Emissions(in percent) in Qatar in 1974 to that in 1977?
Offer a very short reply. 0.31. What is the ratio of the Emissions(in percent) of Cote d'Ivoire in 1974 to that in 1978?
Your answer should be very brief. 0.91. What is the ratio of the Emissions(in percent) of Qatar in 1974 to that in 1978?
Your answer should be compact. 0.34. What is the ratio of the Emissions(in percent) of Cote d'Ivoire in 1974 to that in 1979?
Your response must be concise. 0.91. What is the ratio of the Emissions(in percent) in Maldives in 1974 to that in 1979?
Give a very brief answer. 1. What is the ratio of the Emissions(in percent) of Qatar in 1974 to that in 1979?
Ensure brevity in your answer.  0.5. What is the ratio of the Emissions(in percent) of Singapore in 1974 to that in 1979?
Offer a very short reply. 0.99. What is the ratio of the Emissions(in percent) in Cote d'Ivoire in 1974 to that in 1980?
Provide a succinct answer. 1.02. What is the ratio of the Emissions(in percent) of Qatar in 1974 to that in 1980?
Give a very brief answer. 0.4. What is the ratio of the Emissions(in percent) in Maldives in 1975 to that in 1976?
Your response must be concise. 1. What is the ratio of the Emissions(in percent) of Qatar in 1975 to that in 1976?
Give a very brief answer. 0.33. What is the ratio of the Emissions(in percent) in Singapore in 1975 to that in 1976?
Your answer should be compact. 1. What is the ratio of the Emissions(in percent) of Maldives in 1975 to that in 1977?
Ensure brevity in your answer.  1. What is the ratio of the Emissions(in percent) in Qatar in 1975 to that in 1977?
Your response must be concise. 0.24. What is the ratio of the Emissions(in percent) in Maldives in 1975 to that in 1978?
Offer a terse response. 1. What is the ratio of the Emissions(in percent) in Qatar in 1975 to that in 1978?
Your answer should be compact. 0.27. What is the ratio of the Emissions(in percent) in Singapore in 1975 to that in 1978?
Provide a succinct answer. 0.99. What is the ratio of the Emissions(in percent) in Maldives in 1975 to that in 1979?
Keep it short and to the point. 1. What is the ratio of the Emissions(in percent) of Qatar in 1975 to that in 1979?
Offer a very short reply. 0.39. What is the ratio of the Emissions(in percent) of Singapore in 1975 to that in 1979?
Your response must be concise. 0.99. What is the ratio of the Emissions(in percent) of Cote d'Ivoire in 1975 to that in 1980?
Your answer should be compact. 1.12. What is the ratio of the Emissions(in percent) of Maldives in 1975 to that in 1980?
Offer a very short reply. 1. What is the ratio of the Emissions(in percent) in Qatar in 1975 to that in 1980?
Provide a short and direct response. 0.31. What is the ratio of the Emissions(in percent) of Singapore in 1975 to that in 1980?
Your answer should be compact. 1. What is the ratio of the Emissions(in percent) in Cote d'Ivoire in 1976 to that in 1977?
Offer a very short reply. 1. What is the ratio of the Emissions(in percent) in Qatar in 1976 to that in 1977?
Your response must be concise. 0.72. What is the ratio of the Emissions(in percent) of Cote d'Ivoire in 1976 to that in 1978?
Offer a very short reply. 1. What is the ratio of the Emissions(in percent) in Qatar in 1976 to that in 1978?
Provide a short and direct response. 0.81. What is the ratio of the Emissions(in percent) in Cote d'Ivoire in 1976 to that in 1979?
Your response must be concise. 1. What is the ratio of the Emissions(in percent) in Maldives in 1976 to that in 1979?
Make the answer very short. 1. What is the ratio of the Emissions(in percent) of Qatar in 1976 to that in 1979?
Your answer should be very brief. 1.18. What is the ratio of the Emissions(in percent) of Cote d'Ivoire in 1976 to that in 1980?
Make the answer very short. 1.12. What is the ratio of the Emissions(in percent) in Qatar in 1976 to that in 1980?
Ensure brevity in your answer.  0.94. What is the ratio of the Emissions(in percent) of Singapore in 1976 to that in 1980?
Make the answer very short. 1.01. What is the ratio of the Emissions(in percent) of Qatar in 1977 to that in 1978?
Ensure brevity in your answer.  1.13. What is the ratio of the Emissions(in percent) of Cote d'Ivoire in 1977 to that in 1979?
Provide a succinct answer. 1. What is the ratio of the Emissions(in percent) of Maldives in 1977 to that in 1979?
Keep it short and to the point. 1. What is the ratio of the Emissions(in percent) of Qatar in 1977 to that in 1979?
Give a very brief answer. 1.64. What is the ratio of the Emissions(in percent) in Singapore in 1977 to that in 1979?
Offer a very short reply. 0.99. What is the ratio of the Emissions(in percent) in Cote d'Ivoire in 1977 to that in 1980?
Give a very brief answer. 1.12. What is the ratio of the Emissions(in percent) of Maldives in 1977 to that in 1980?
Offer a very short reply. 1. What is the ratio of the Emissions(in percent) in Qatar in 1977 to that in 1980?
Provide a short and direct response. 1.31. What is the ratio of the Emissions(in percent) of Singapore in 1977 to that in 1980?
Your response must be concise. 1.01. What is the ratio of the Emissions(in percent) in Maldives in 1978 to that in 1979?
Provide a succinct answer. 1. What is the ratio of the Emissions(in percent) of Qatar in 1978 to that in 1979?
Your answer should be compact. 1.46. What is the ratio of the Emissions(in percent) of Cote d'Ivoire in 1978 to that in 1980?
Provide a short and direct response. 1.12. What is the ratio of the Emissions(in percent) of Qatar in 1978 to that in 1980?
Give a very brief answer. 1.16. What is the ratio of the Emissions(in percent) in Singapore in 1978 to that in 1980?
Offer a terse response. 1.01. What is the ratio of the Emissions(in percent) in Cote d'Ivoire in 1979 to that in 1980?
Provide a short and direct response. 1.12. What is the ratio of the Emissions(in percent) of Maldives in 1979 to that in 1980?
Ensure brevity in your answer.  1. What is the ratio of the Emissions(in percent) in Qatar in 1979 to that in 1980?
Give a very brief answer. 0.8. What is the ratio of the Emissions(in percent) in Singapore in 1979 to that in 1980?
Offer a terse response. 1.01. What is the difference between the highest and the second highest Emissions(in percent) in Cote d'Ivoire?
Your answer should be very brief. 0. What is the difference between the highest and the second highest Emissions(in percent) in Qatar?
Your answer should be compact. 1.79. What is the difference between the highest and the second highest Emissions(in percent) in Singapore?
Provide a short and direct response. 0.19. What is the difference between the highest and the lowest Emissions(in percent) in Cote d'Ivoire?
Your answer should be compact. 10.43. What is the difference between the highest and the lowest Emissions(in percent) in Maldives?
Ensure brevity in your answer.  0. What is the difference between the highest and the lowest Emissions(in percent) in Qatar?
Offer a very short reply. 12.33. What is the difference between the highest and the lowest Emissions(in percent) of Singapore?
Give a very brief answer. 1.25. 